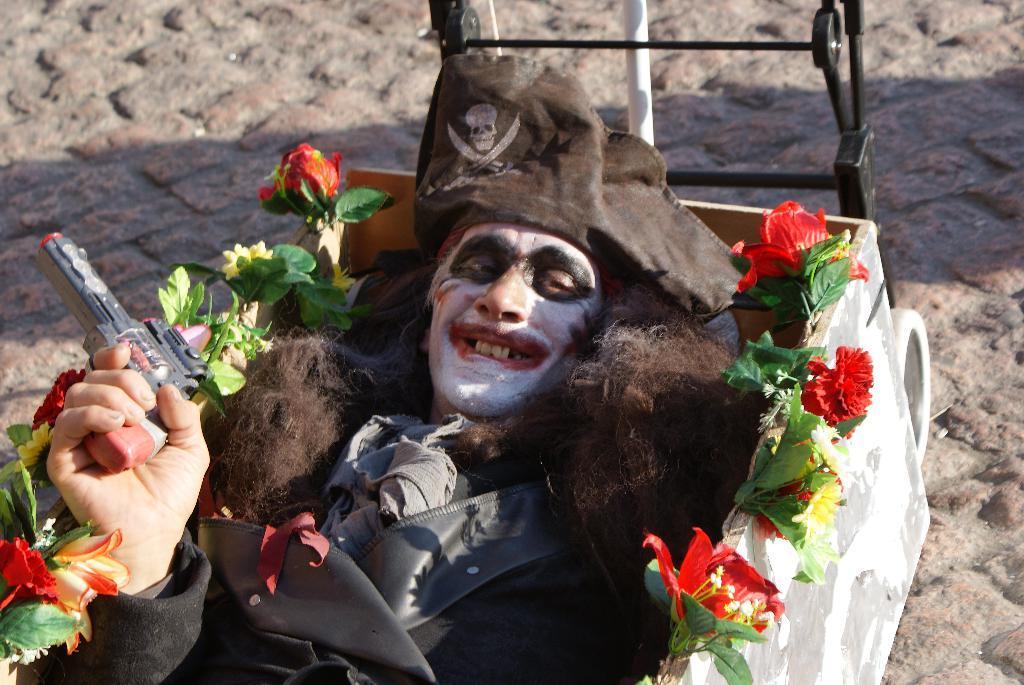How would you summarize this image in a sentence or two? In this picture there is a man in the center of the image, by holding a gun in a box and there are flowers around the box. 